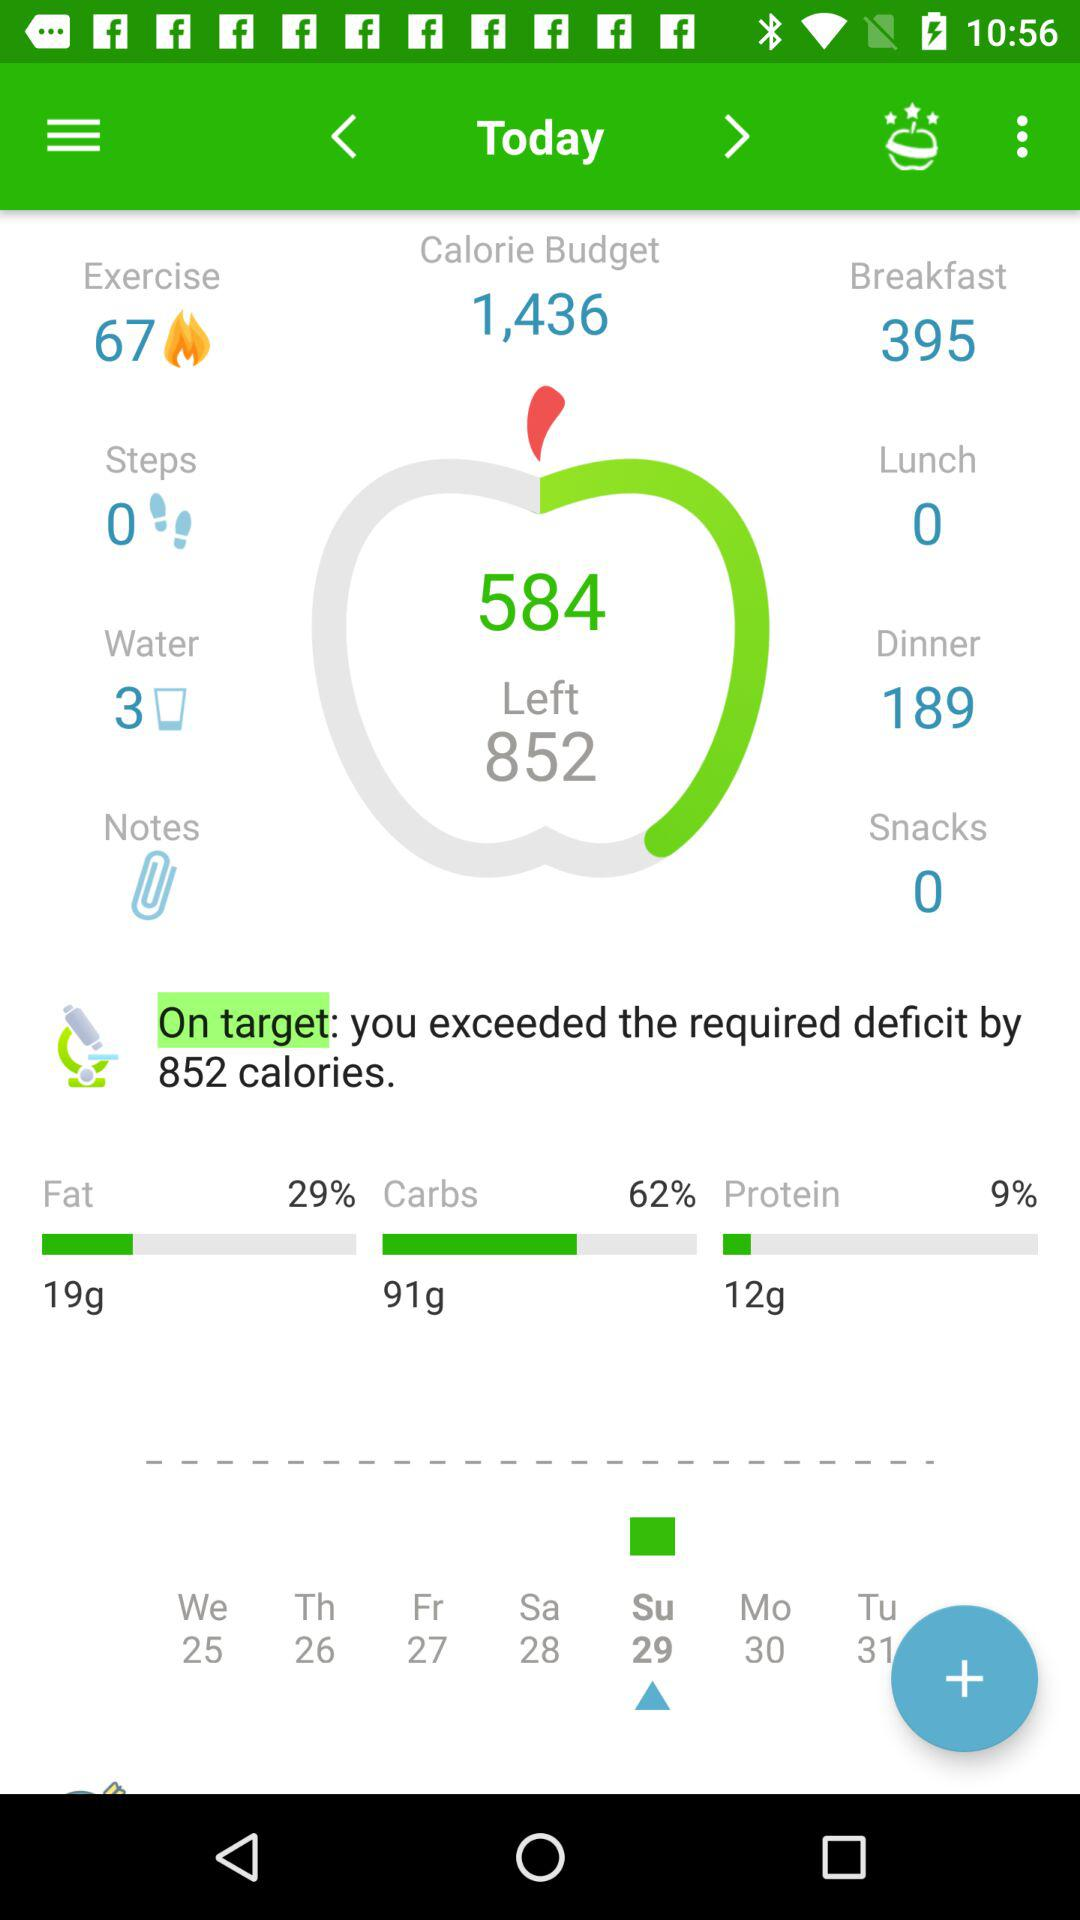What is the selected date? The selected date is Sunday, 29. 